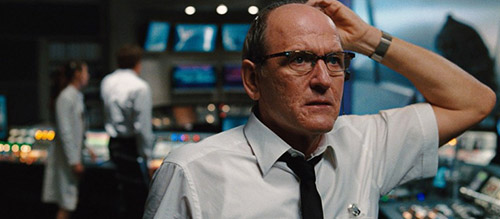What is this photo about? This photo captures an intense moment of a character, presumably based on his attire and setting, who is a senior newsroom producer. He is depicted in a busy newsroom, surrounded by monitors displaying various broadcasts. Dressed in a formal white shirt and black tie, he projects a commanding but thoughtful presence. His gesture of hand-to-head indicates deep contemplation or concern, suggesting a critical moment in his professional role. The backdrop, filled with blurred figures actively engaging at their desks, adds a dynamic and realistic touch to the scene, highlighting the urgency commonly associated with media environments. 